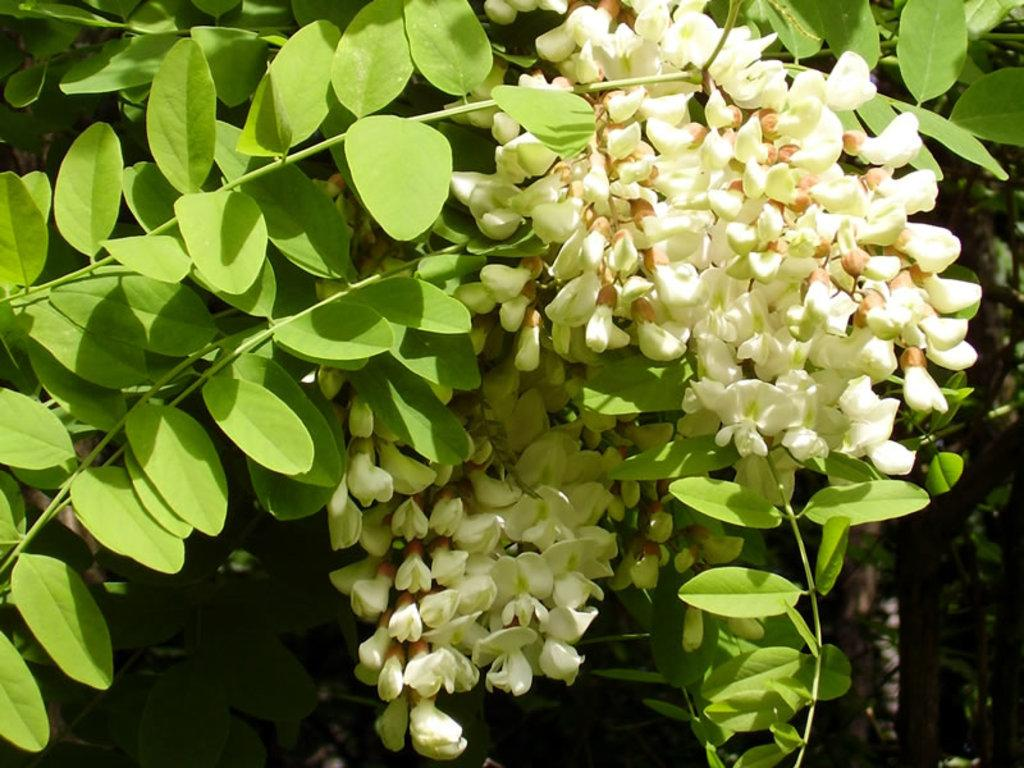What can be seen in the image that resembles tree parts? There are branches in the image. What are the characteristics of the flowers on the branches? The flowers on the branches have a white color. What is the color of the leaves on the branches? The leaves on the branches have a green color. How would you describe the background of the image? The background of the image is dark in color. How many snails can be seen crawling on the branches in the image? There are no snails visible in the image; it only features branches with white flowers and green leaves. What type of fruit is hanging from the branches in the image? There is no fruit present on the branches in the image; they only have flowers and leaves. 